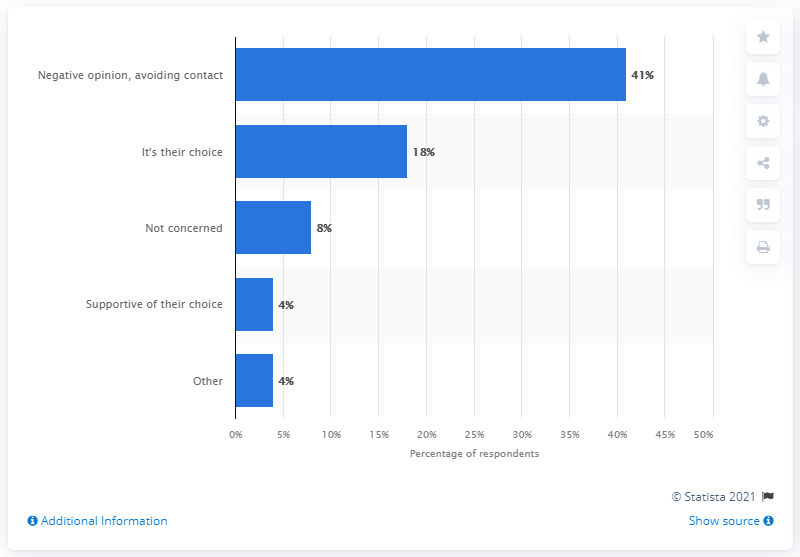Highlight a few significant elements in this photo. According to a survey of U.S. respondents, 41% stated that they felt negatively or avoided contact with people who chose not to wear a face mask during the COVID-19 pandemic. 